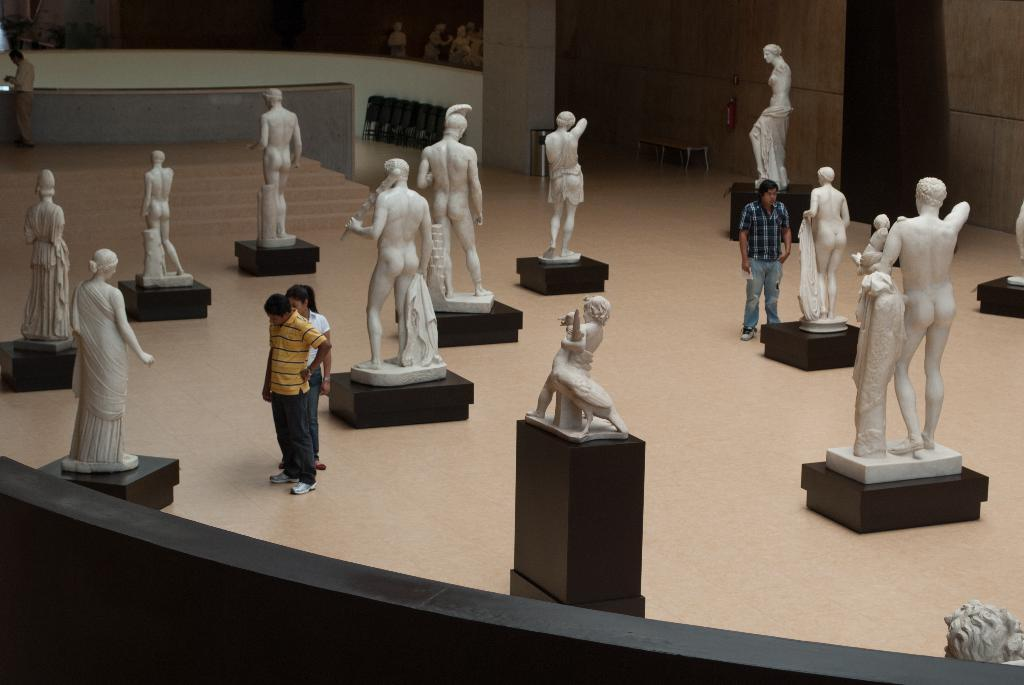What type of objects are on the floor in the image? There are statues of human beings on the floor. Can you describe the people in the image? There are people in the image. What is visible in the background of the image? There is a wall in the background of the image. What type of account is being discussed by the people in the image? There is no indication of any account being discussed in the image. 